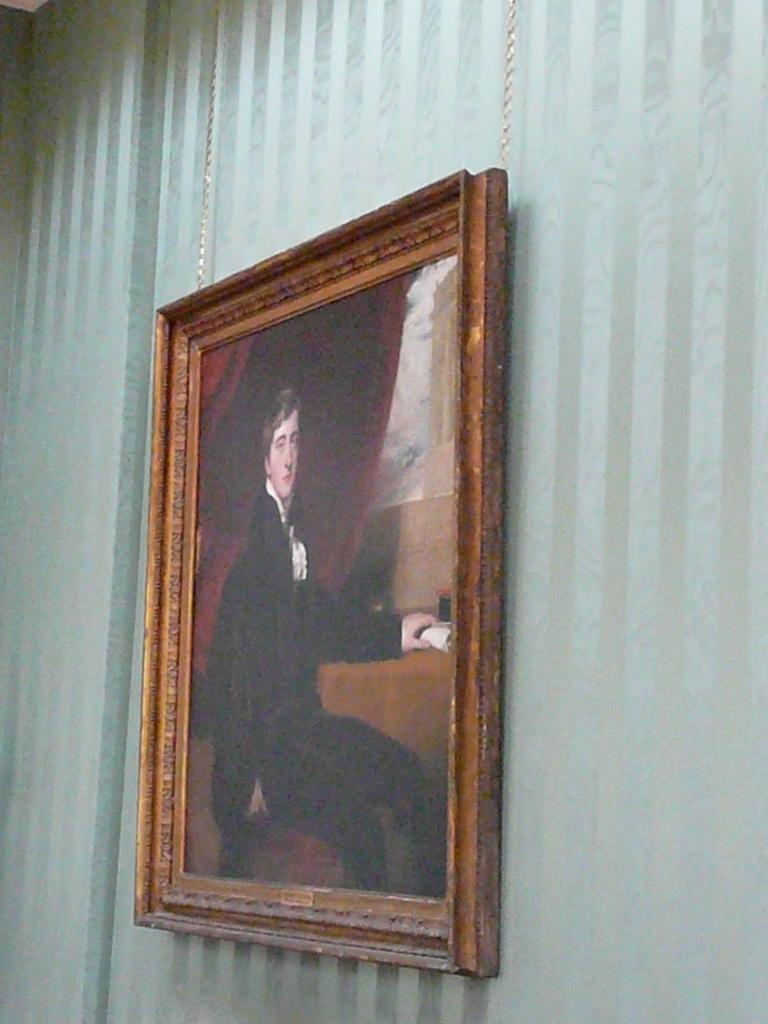Can you describe this image briefly? In this image in the center there is one photo frame on the wall. 